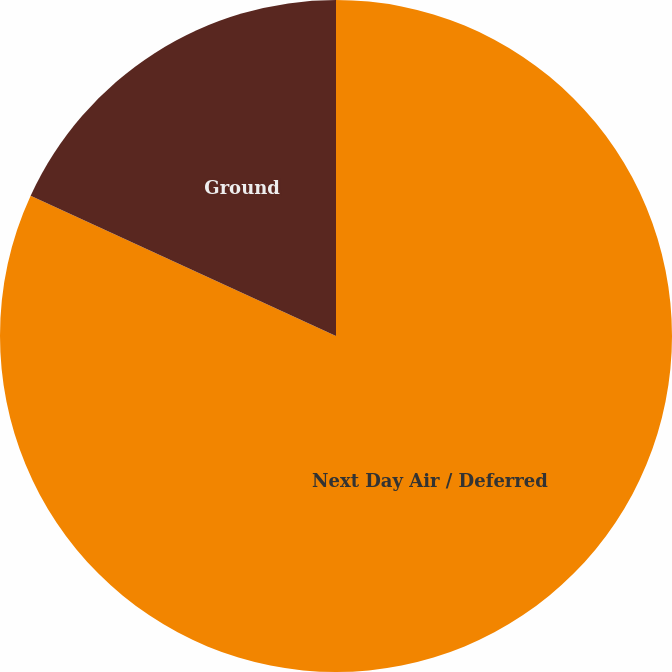Convert chart. <chart><loc_0><loc_0><loc_500><loc_500><pie_chart><fcel>Next Day Air / Deferred<fcel>Ground<nl><fcel>81.85%<fcel>18.15%<nl></chart> 